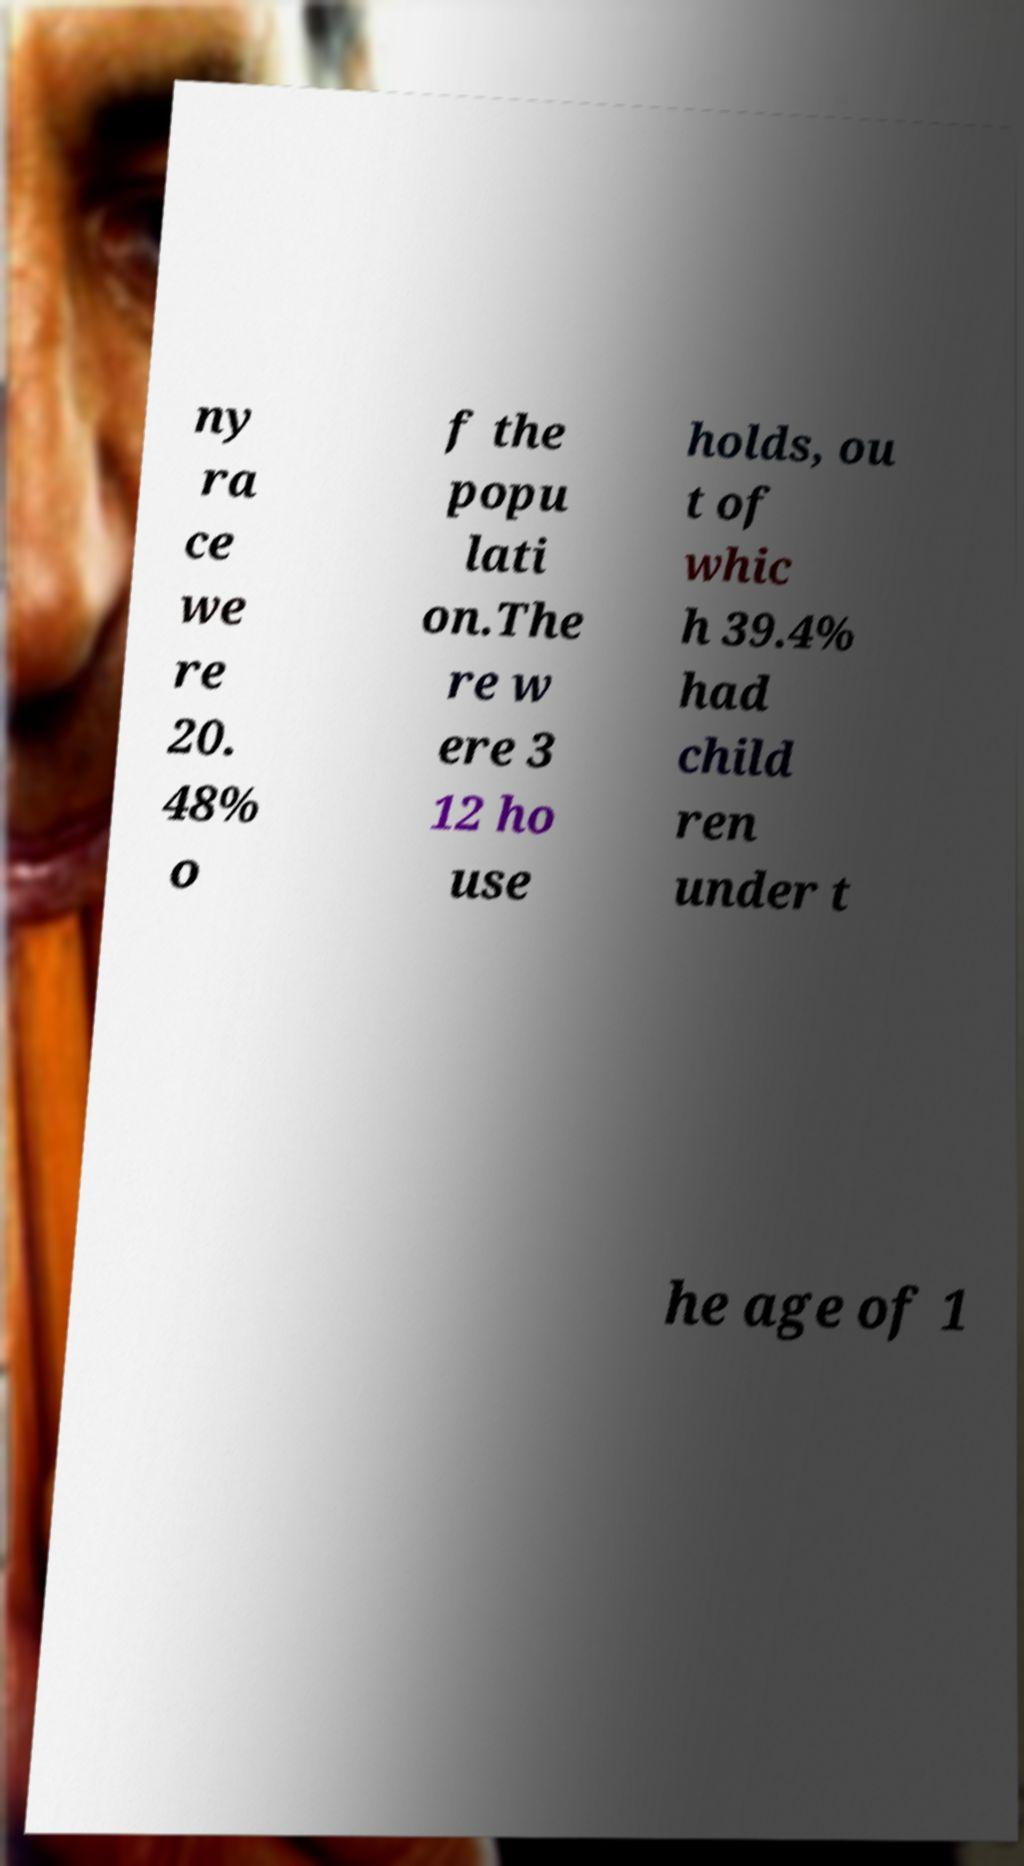What messages or text are displayed in this image? I need them in a readable, typed format. ny ra ce we re 20. 48% o f the popu lati on.The re w ere 3 12 ho use holds, ou t of whic h 39.4% had child ren under t he age of 1 